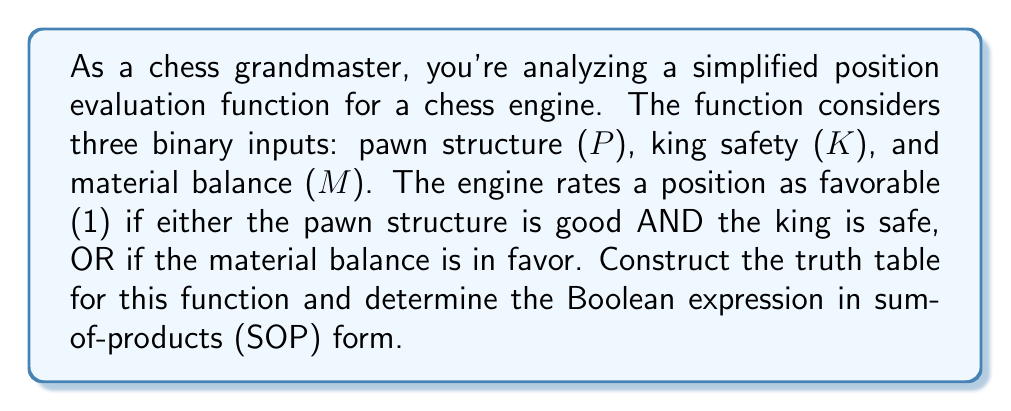What is the answer to this math problem? Let's approach this step-by-step:

1) First, we need to construct the truth table. We have 3 inputs (P, K, M) and 1 output (F for favorable).

2) The truth table will have $2^3 = 8$ rows for all possible input combinations.

3) We can represent the function as: $F = (P \land K) \lor M$

4) Let's fill in the truth table:

   P | K | M | F
   ---------------
   0 | 0 | 0 | 0
   0 | 0 | 1 | 1
   0 | 1 | 0 | 0
   0 | 1 | 1 | 1
   1 | 0 | 0 | 0
   1 | 0 | 1 | 1
   1 | 1 | 0 | 1
   1 | 1 | 1 | 1

5) To write the Boolean expression in sum-of-products (SOP) form, we need to consider all rows where F = 1:

   $F = \overline{P}\overline{K}M \lor \overline{P}KM \lor P\overline{K}M \lor PKM \lor PK\overline{M}$

6) This can be simplified to:

   $F = M \lor PK$

This matches our original function description: the position is favorable if either the material balance is in favor (M) OR both the pawn structure is good AND the king is safe (PK).
Answer: $F = M \lor PK$ 